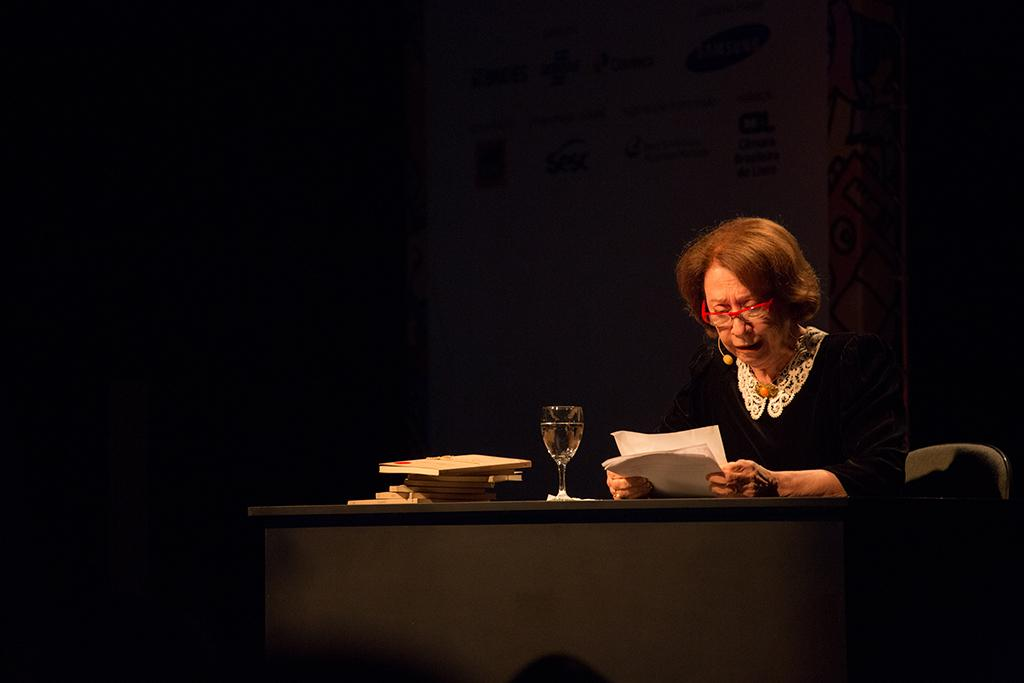Who is the main subject in the image? There is a lady in the image. What is the lady doing in the image? The lady is sitting on a table and reading a document. What can be seen beside the lady? There is a glass of juice beside the lady. What type of twist is the lady performing in the image? There is no twist being performed in the image; the lady is sitting and reading a document. 